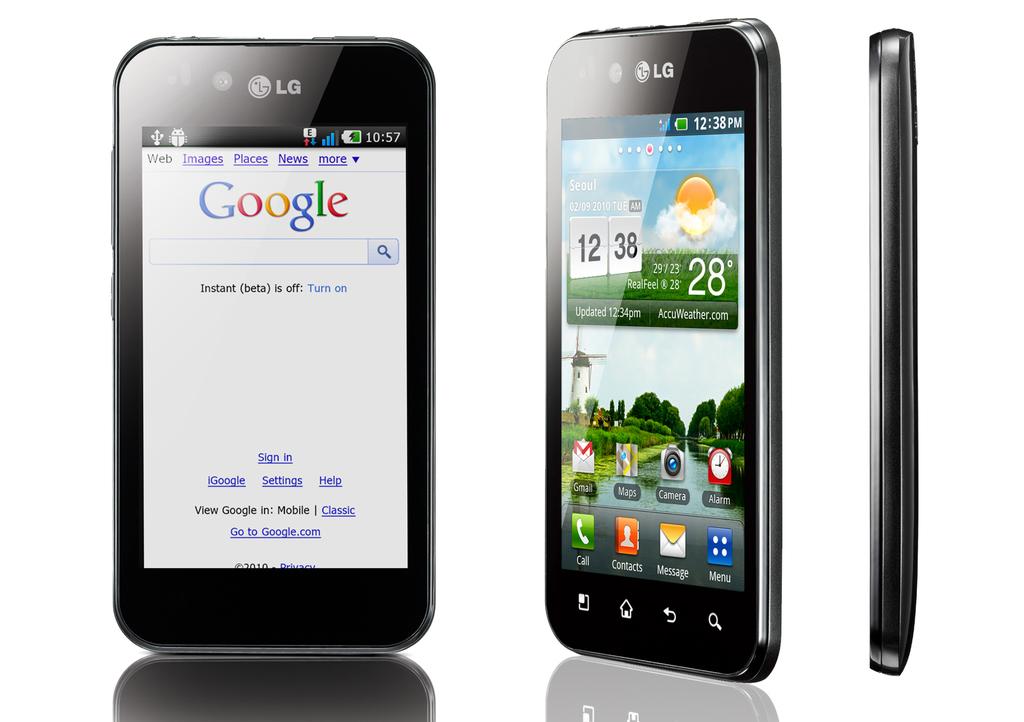What search engine is shown on the phone?
Make the answer very short. Google. What time is shown on the phone on the right?
Offer a very short reply. 12:38. 